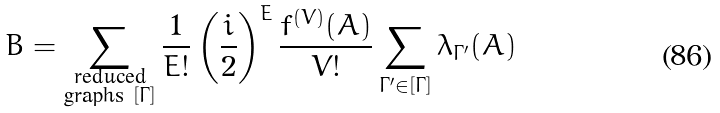<formula> <loc_0><loc_0><loc_500><loc_500>B = \sum _ { \substack { \text {reduced} \\ \text {graphs } [ \Gamma ] } } \frac { 1 } { E ! } \left ( \frac { i } { 2 } \right ) ^ { E } \frac { f ^ { ( V ) } ( A ) } { V ! } \sum _ { \Gamma ^ { \prime } \in [ \Gamma ] } \lambda _ { \Gamma ^ { \prime } } ( A )</formula> 